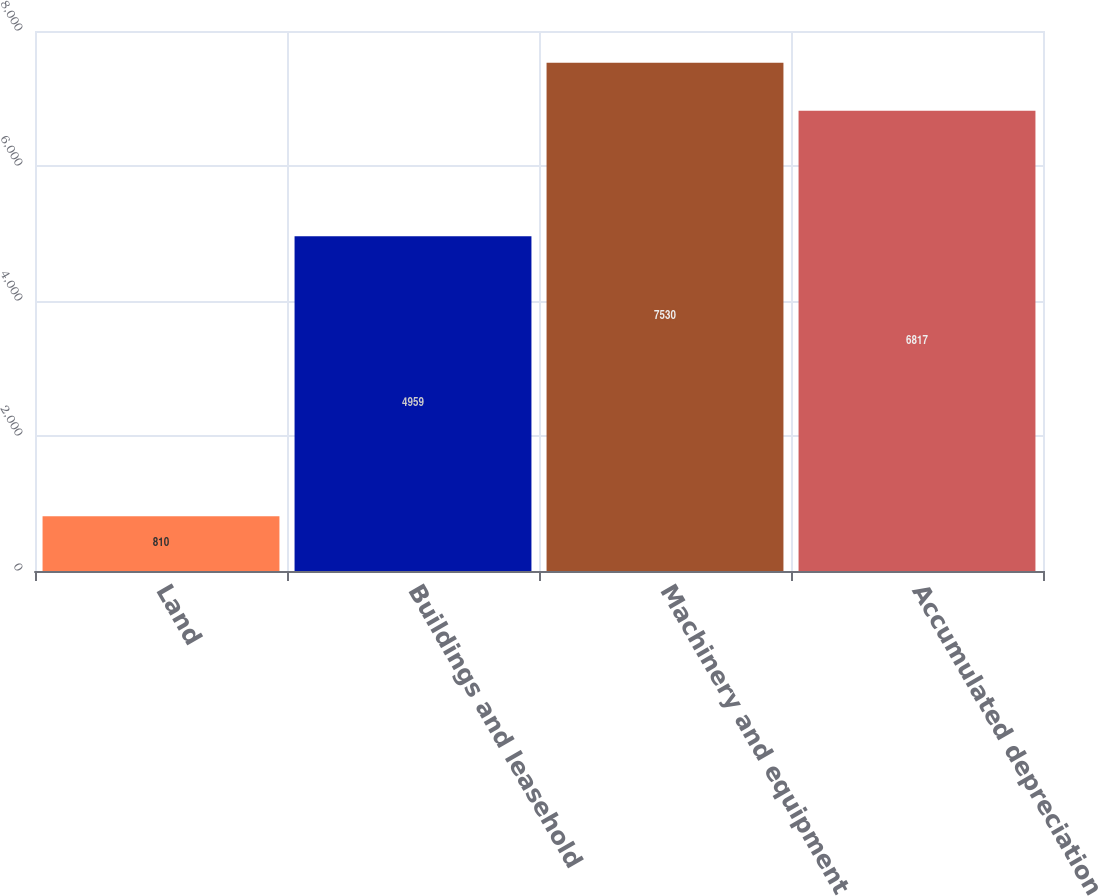Convert chart to OTSL. <chart><loc_0><loc_0><loc_500><loc_500><bar_chart><fcel>Land<fcel>Buildings and leasehold<fcel>Machinery and equipment<fcel>Accumulated depreciation<nl><fcel>810<fcel>4959<fcel>7530<fcel>6817<nl></chart> 